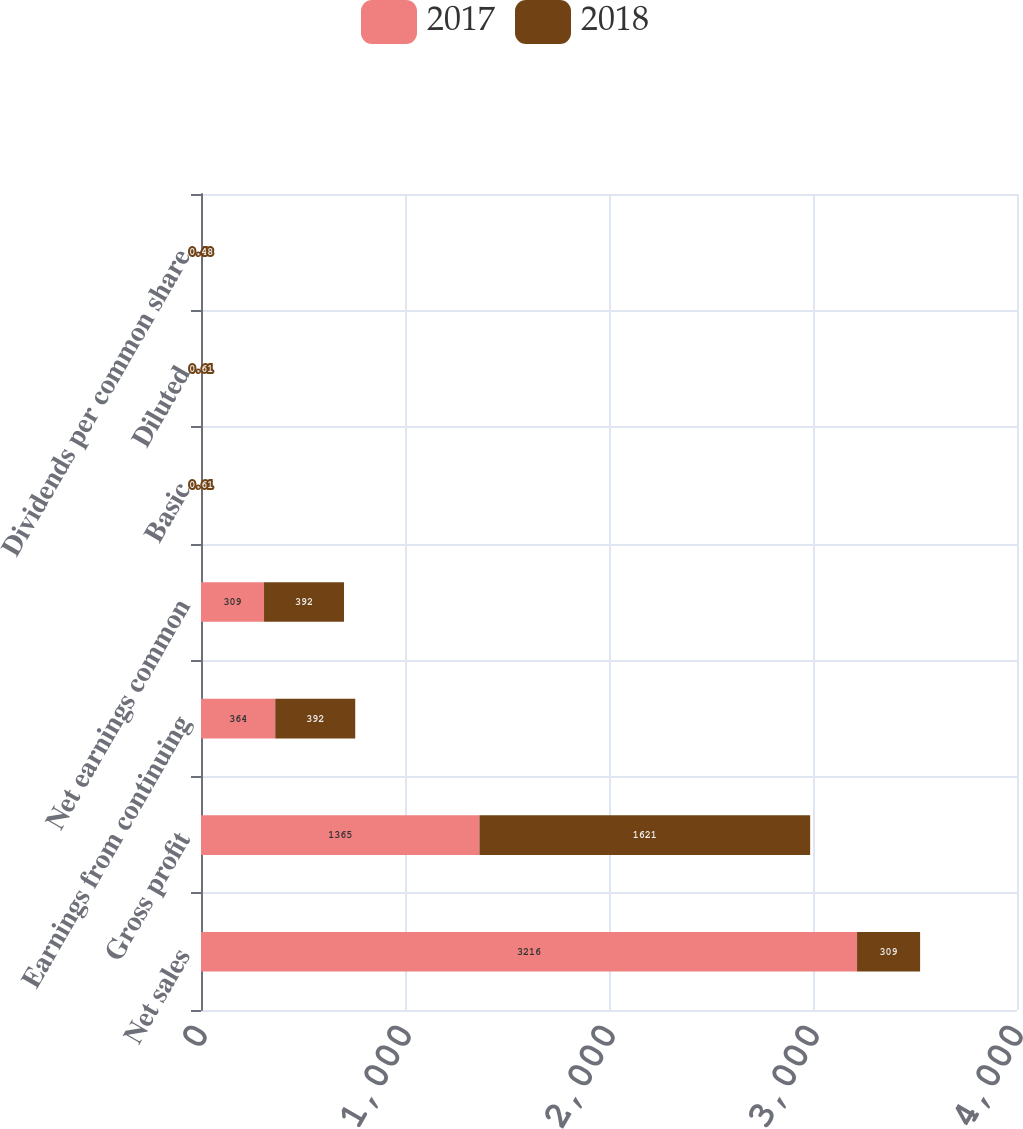Convert chart. <chart><loc_0><loc_0><loc_500><loc_500><stacked_bar_chart><ecel><fcel>Net sales<fcel>Gross profit<fcel>Earnings from continuing<fcel>Net earnings common<fcel>Basic<fcel>Diluted<fcel>Dividends per common share<nl><fcel>2017<fcel>3216<fcel>1365<fcel>364<fcel>309<fcel>0.56<fcel>0.56<fcel>0.48<nl><fcel>2018<fcel>309<fcel>1621<fcel>392<fcel>392<fcel>0.61<fcel>0.61<fcel>0.48<nl></chart> 